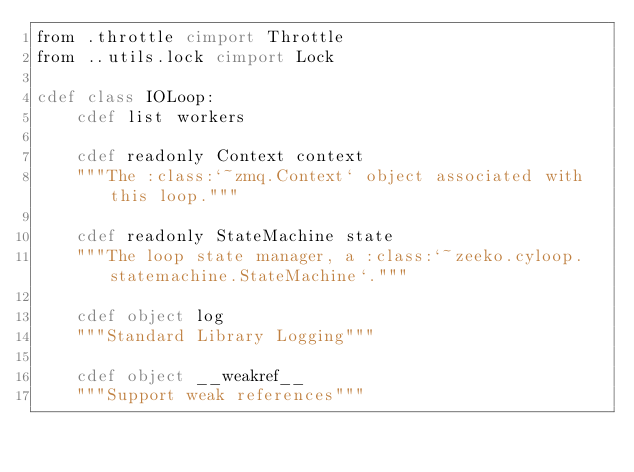Convert code to text. <code><loc_0><loc_0><loc_500><loc_500><_Cython_>from .throttle cimport Throttle
from ..utils.lock cimport Lock

cdef class IOLoop:
    cdef list workers
    
    cdef readonly Context context
    """The :class:`~zmq.Context` object associated with this loop."""
    
    cdef readonly StateMachine state
    """The loop state manager, a :class:`~zeeko.cyloop.statemachine.StateMachine`."""
    
    cdef object log
    """Standard Library Logging"""
    
    cdef object __weakref__
    """Support weak references"""</code> 